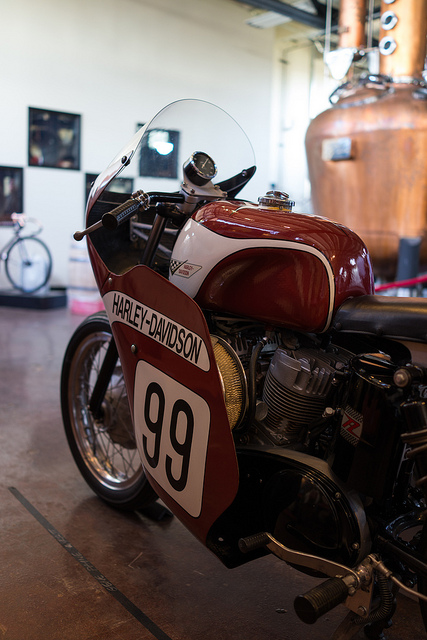Identify the text contained in this image. HARLEY DAVIDSON 99 